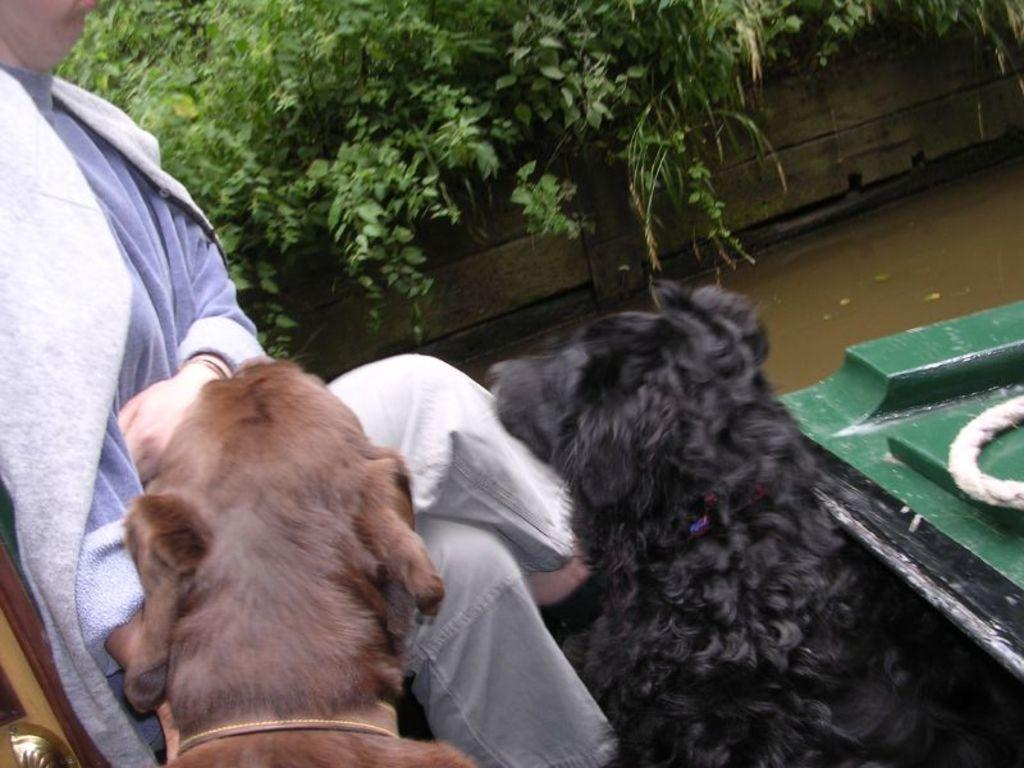What animals can be seen in the image? There are dogs in the image. What is the person in the image doing? The person is sitting on a boat in the image. What can be seen in the background of the image? There is water, plants, and a wall visible in the background of the image. What object is on the boat with the person? There is a white color rope on the boat in the image. How many guitars are being played by the dogs in the image? There are no guitars present in the image, and the dogs are not playing any instruments. 